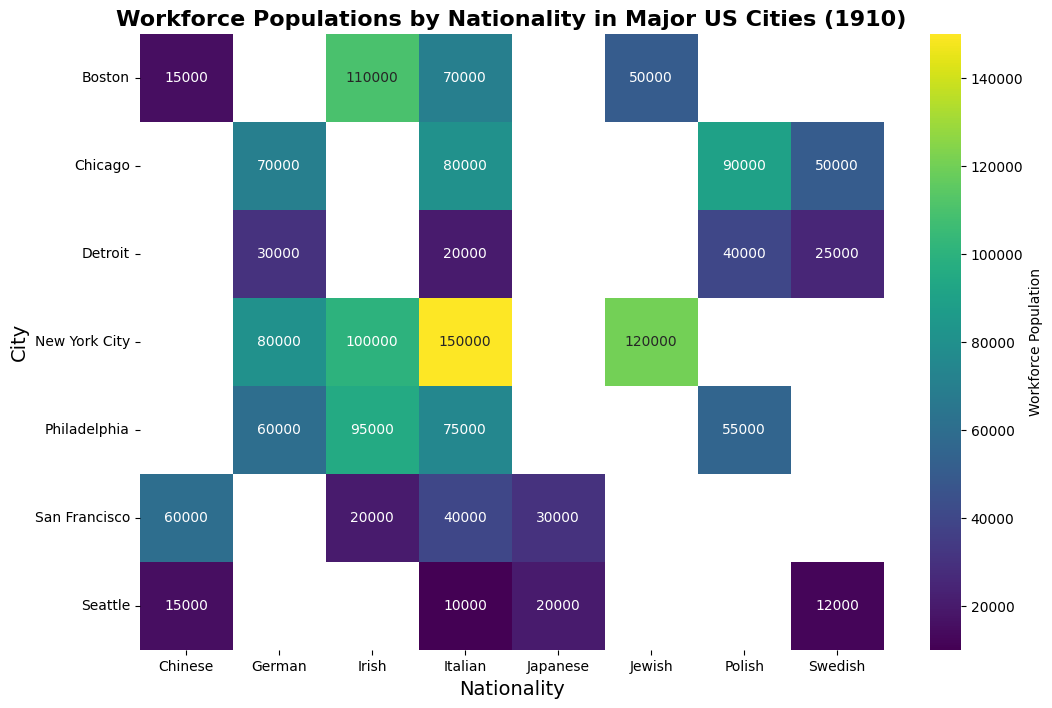What city has the highest workforce population of Italians? Look for the row where the 'Italian' column has the darkest color. New York City shows the highest value of 150,000.
Answer: New York City Which city shows a significant workforce population for both Irish and Jewish immigrants? Compare the rows where both 'Irish' and 'Jewish' columns have significant annotations. New York City has 100,000 for Irish and 120,000 for Jewish.
Answer: New York City Does San Francisco have a higher workforce population for Chinese or Japanese immigrants? Check the numbers in the 'Chinese' and 'Japanese' columns for San Francisco. The workforce population for Chinese is 60,000 and for Japanese is 30,000.
Answer: Chinese Among Boston, Philadelphia, and Seattle, which has the highest total workforce population for Swedish immigrants? Compare the Swedish workforce population numbers for Boston, Philadelphia, and Seattle. The values are 0, 0, and 12,000 respectively.
Answer: Seattle What is the combined workforce population of Irish and Italian immigrants in Philadelphia? Sum the workforce populations for 'Irish' and 'Italian' in the Philadelphia row. The values are 95,000 and 75,000 respectively, summing to 170,000.
Answer: 170,000 Is the workforce population of Polish immigrants greater in Chicago than in Detroit? Compare the workforce populations in the 'Polish' column for Chicago (90,000) and Detroit (40,000). Chicago's is greater.
Answer: Yes Which city shows a nearly equal workforce population for German and Jewish immigrants? Look for a city where the values in the 'German' and 'Jewish' columns are close. New York City shows 80,000 for German and 120,000 for Jewish, which are not close. Only Boston has 0 for both German and Jewish.
Answer: None, No City By roughly how much does the workforce population of Swedish immigrants in Detroit differ from that in Seattle? Subtract the value of the 'Swedish' column in Detroit (25,000) from that in Seattle (12,000). The difference is 13,000.
Answer: 13,000 Which nationality has the most consistent workforce population across all cities? Look for the nationality column where the values appear similar across multiple cities. The 'Italian' and 'Irish' nationalities show prominent values consistently across different cities.
Answer: Italian 